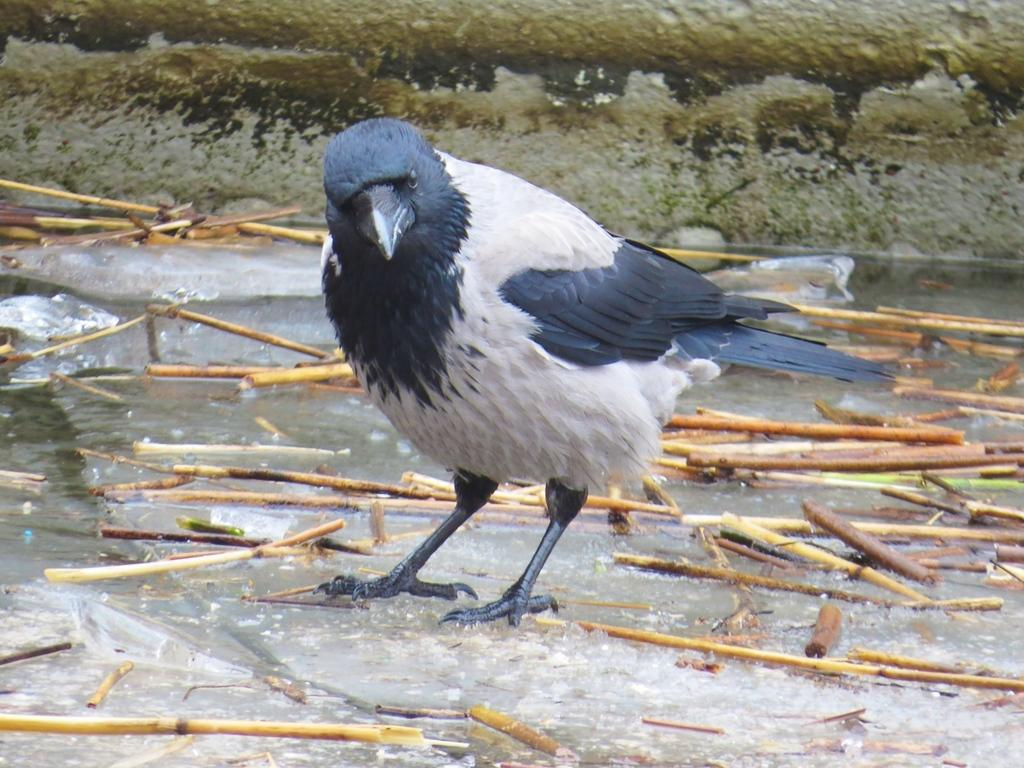What type of animal is in the image? There is a bird in the image. Where is the bird located? The bird is standing on the water. What else can be seen in the water? There are wooden sticks in the water. What type of land can be seen in the image? There is no land visible in the image; it features a bird standing on water with wooden sticks. 